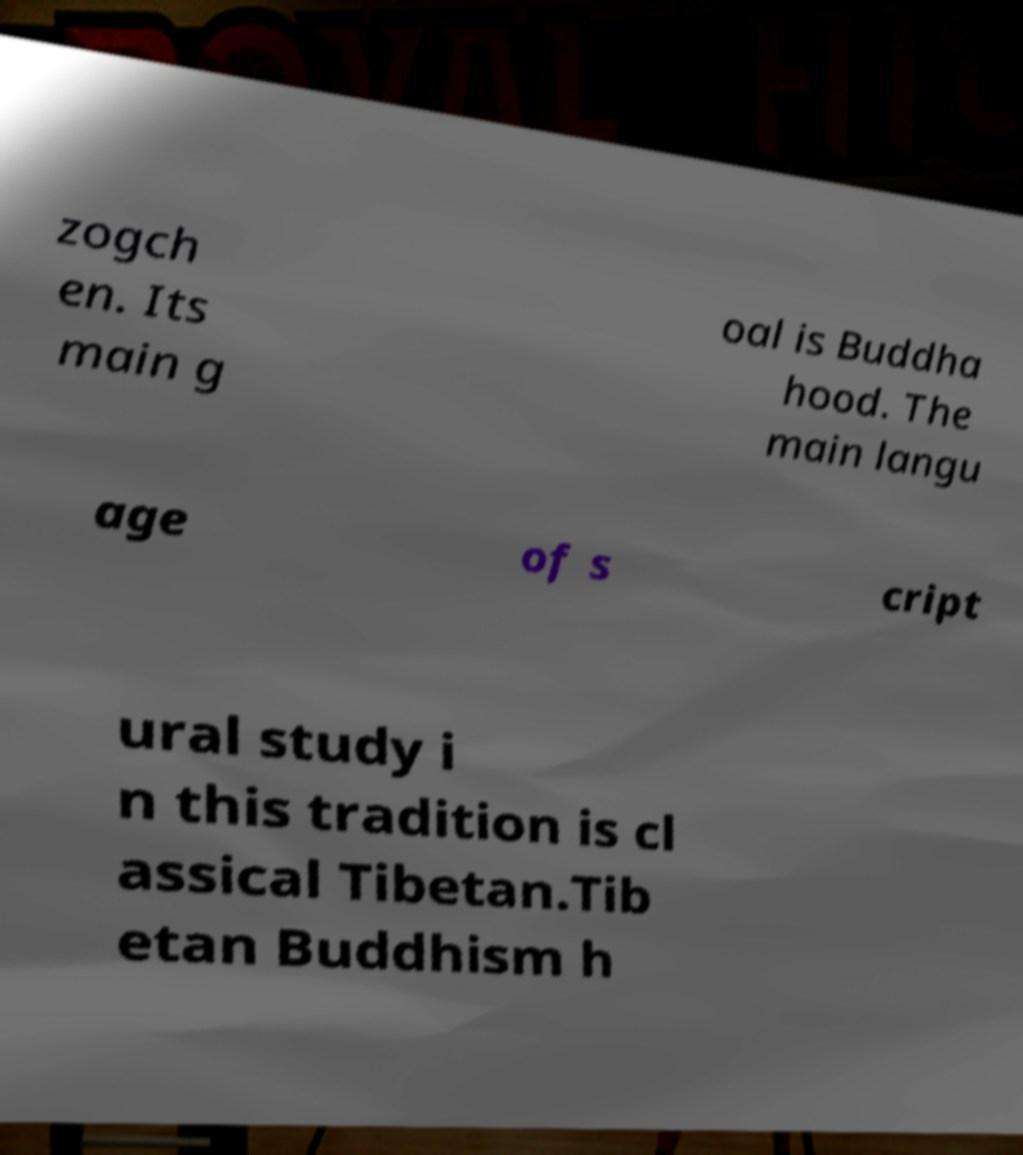Could you extract and type out the text from this image? zogch en. Its main g oal is Buddha hood. The main langu age of s cript ural study i n this tradition is cl assical Tibetan.Tib etan Buddhism h 